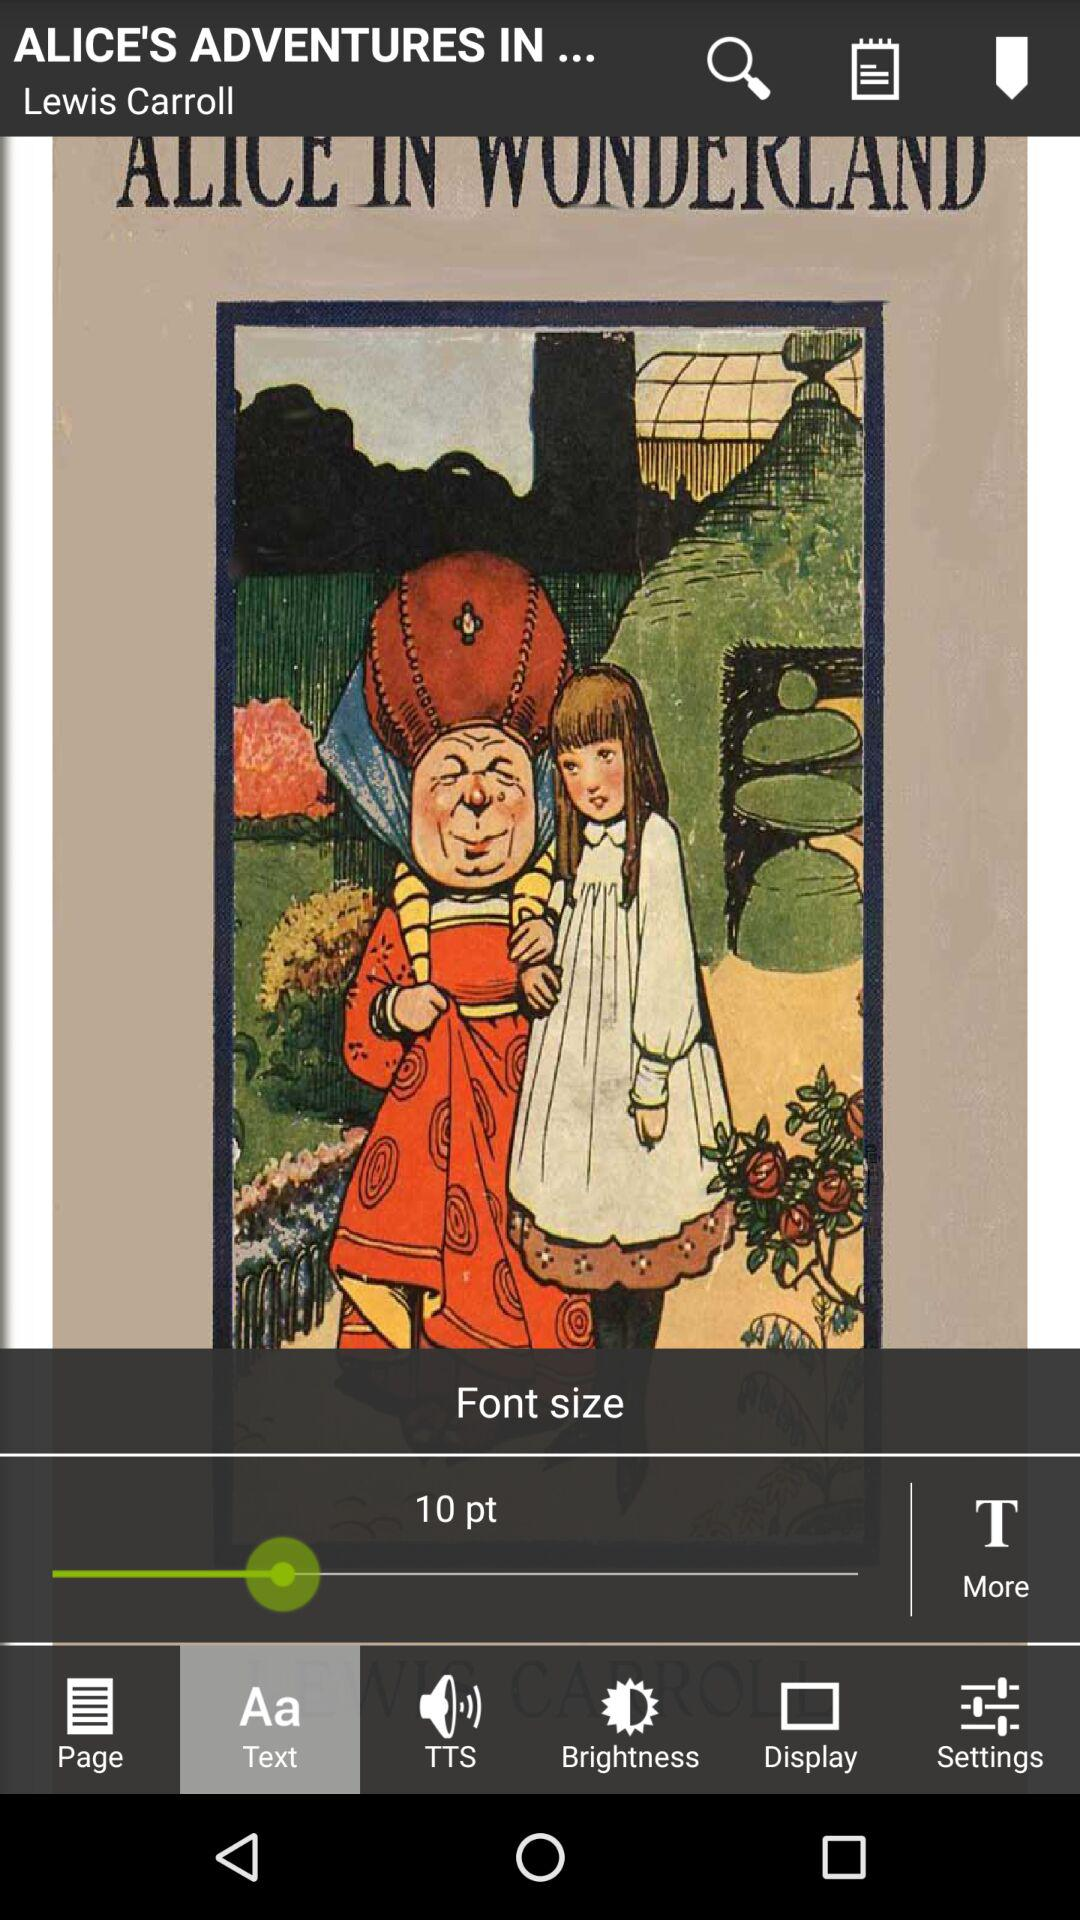What is the selected font size? The selected font size is 10 points. 